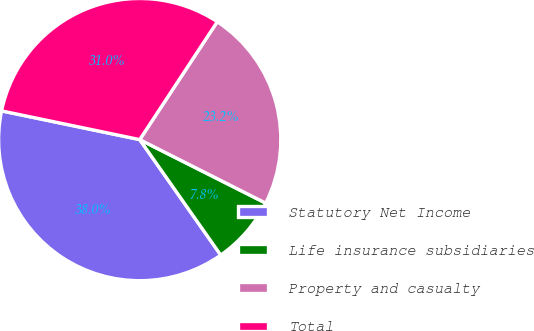Convert chart to OTSL. <chart><loc_0><loc_0><loc_500><loc_500><pie_chart><fcel>Statutory Net Income<fcel>Life insurance subsidiaries<fcel>Property and casualty<fcel>Total<nl><fcel>38.0%<fcel>7.83%<fcel>23.17%<fcel>31.0%<nl></chart> 